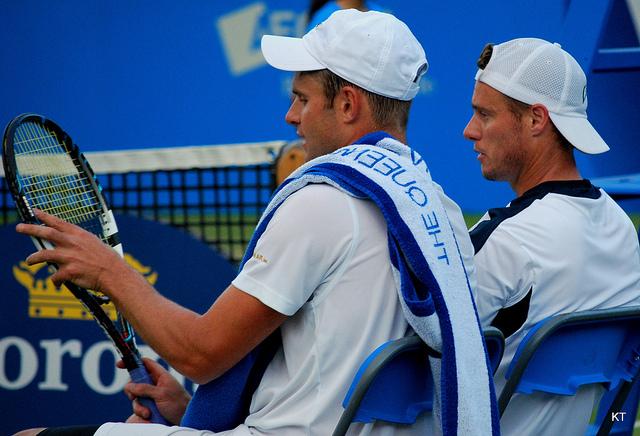What color are the hats the men are wearing?
Be succinct. White. What are the men holding?
Short answer required. Tennis racket. Are both men wearing hats?
Give a very brief answer. Yes. What sport is this?
Keep it brief. Tennis. Are the men wearing gloves?
Write a very short answer. No. What sport are they playing?
Be succinct. Tennis. What is the man in front holding?
Keep it brief. Tennis racket. 